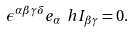<formula> <loc_0><loc_0><loc_500><loc_500>\epsilon ^ { \alpha \beta \gamma \delta } e _ { \alpha } \ h { I } _ { \beta \gamma } = 0 .</formula> 